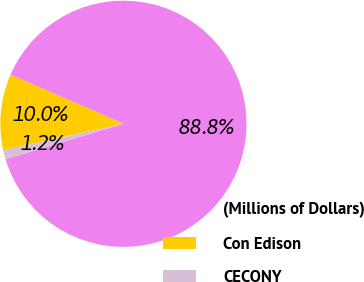Convert chart. <chart><loc_0><loc_0><loc_500><loc_500><pie_chart><fcel>(Millions of Dollars)<fcel>Con Edison<fcel>CECONY<nl><fcel>88.85%<fcel>9.96%<fcel>1.19%<nl></chart> 